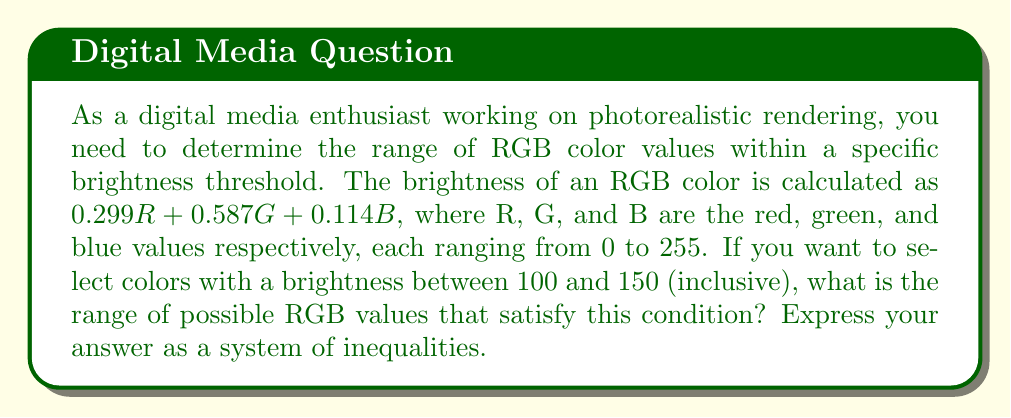Could you help me with this problem? Let's approach this step-by-step:

1) First, we need to set up our brightness inequality:

   $$100 \leq 0.299R + 0.587G + 0.114B \leq 150$$

2) We know that R, G, and B each range from 0 to 255. So we can add these constraints:

   $$0 \leq R \leq 255$$
   $$0 \leq G \leq 255$$
   $$0 \leq B \leq 255$$

3) Now, let's consider the minimum and maximum possible values for each color component:

   Minimum: If two components are 0, the third component's minimum value can be calculated:
   
   For R: $100 \leq 0.299R + 0 + 0 \leq 150$
   $$\frac{100}{0.299} \leq R \leq \frac{150}{0.299}$$
   $$334.45 \leq R \leq 501.67$$

   For G: $100 \leq 0 + 0.587G + 0 \leq 150$
   $$\frac{100}{0.587} \leq G \leq \frac{150}{0.587}$$
   $$170.36 \leq G \leq 255.54$$

   For B: $100 \leq 0 + 0 + 0.114B \leq 150$
   $$\frac{100}{0.114} \leq B \leq \frac{150}{0.114}$$
   $$877.19 \leq B \leq 1315.79$$

4) Considering the original constraints (0 to 255), we can refine these ranges:

   $$0 \leq R \leq 255$$
   $$0 \leq G \leq 255$$
   $$0 \leq B \leq 255$$

5) The final system of inequalities combines all these conditions:

   $$100 \leq 0.299R + 0.587G + 0.114B \leq 150$$
   $$0 \leq R \leq 255$$
   $$0 \leq G \leq 255$$
   $$0 \leq B \leq 255$$
Answer: The range of possible RGB values satisfying the brightness condition is given by the system of inequalities:

$$100 \leq 0.299R + 0.587G + 0.114B \leq 150$$
$$0 \leq R \leq 255$$
$$0 \leq G \leq 255$$
$$0 \leq B \leq 255$$ 